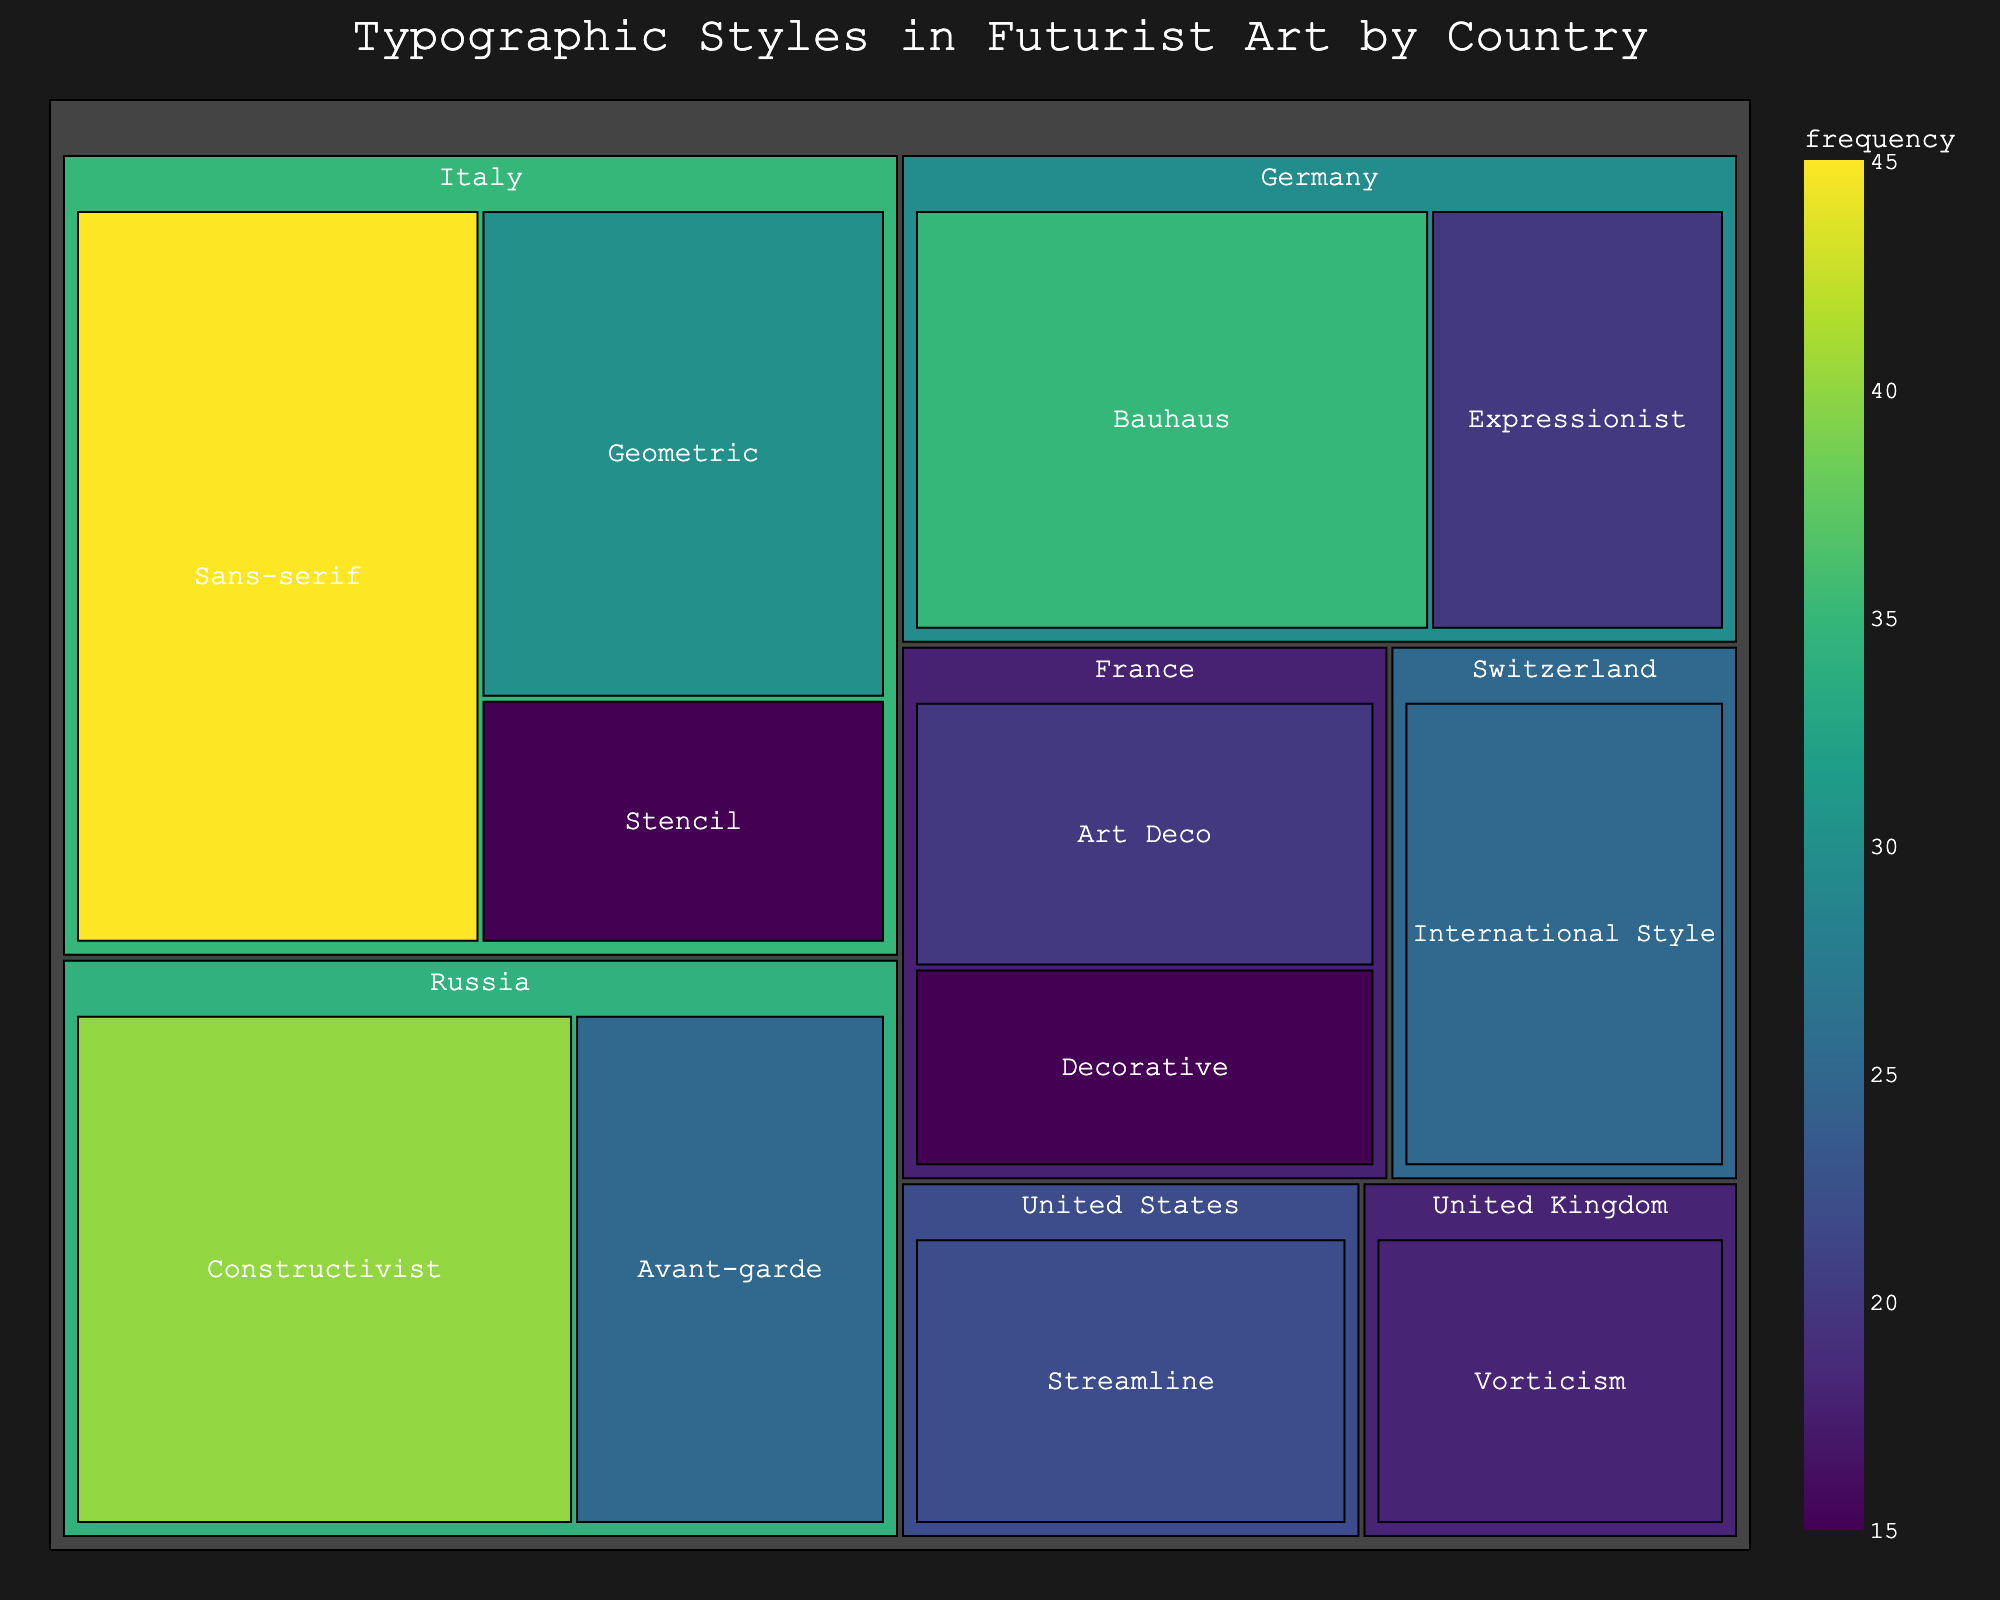How many countries are represented in the typographic style data? The treemap shows different typographic styles divided by country. To determine the number of countries represented, count the main branches (countries) in the treemap.
Answer: 7 Which country has the highest frequency of a single typographic style? To find this, look at the individual typographic styles within each country and identify the one with the highest frequency. The highest is Sans-serif in Italy with a frequency of 45.
Answer: Italy What is the combined frequency of the Art Deco and Decorative styles in France? Locate the two styles within France and sum their frequencies. Art Deco has a frequency of 20, and Decorative has a frequency of 15. Adding these together gives 35.
Answer: 35 Which typographic style in Germany has a higher frequency? Compare the frequencies of the two typographic styles listed under Germany. Bauhaus has a frequency of 35, and Expressionist has a frequency of 20.
Answer: Bauhaus What is the average frequency of typographic styles in Russia? Find the total frequency for Russia by summing the frequencies for Constructivist (40) and Avant-garde (25). The sum is 65. Divide this by the number of styles (2) to get the average.
Answer: 32.5 Which country has the least represented typographic style by frequency, and what is it? Identify the country and style with the lowest frequency in the treemap. The lowest frequency is Stencil in Italy with a frequency of 15.
Answer: Italy, Stencil What is the total frequency of all typographic styles combined in the data? Sum all the individual frequencies from the data: 45 + 30 + 15 + 40 + 25 + 20 + 15 + 35 + 20 + 18 + 22 + 25 = 310.
Answer: 310 How does the frequency of Vorticism in the United Kingdom compare to the International Style in Switzerland? Compare the frequencies: Vorticism in the UK is 18, and International Style in Switzerland is 25. Therefore, International Style in Switzerland has a higher frequency.
Answer: Switzerland, International Style What portion of the total frequency is contributed by styles from Italy? Calculate the total frequency for Italy: Sans-serif (45) + Geometric (30) + Stencil (15) = 90. Then, divide by the total combined frequency (310) and multiply by 100 to get the percentage.
Answer: ~29% Which country has more distinct typographic styles represented, Germany or the United States, and by how many? Count the typographic styles for each country. Germany has Bauhaus and Expressionist (2 styles), and the United States has Streamline (1 style). Germany has one more style than the United States.
Answer: Germany, by 1 